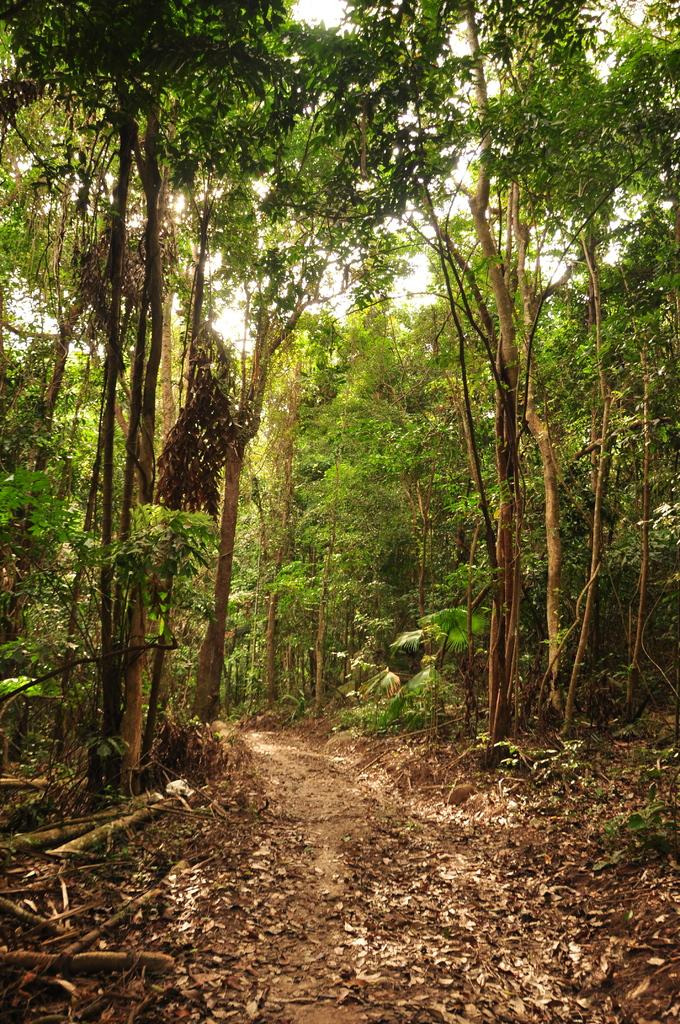What type of vegetation can be seen in the image? There are trees and plants in the image. What is present on the ground in the image? Leaves are present on the ground in the image. What else can be found in the image besides vegetation? There are sticks in the image. What is visible in the background of the image? The sky is visible in the image. What religious symbols can be seen in the image? There are no religious symbols present in the image. How much does the quarter-sized object weigh in the image? There is no quarter-sized object present in the image. 